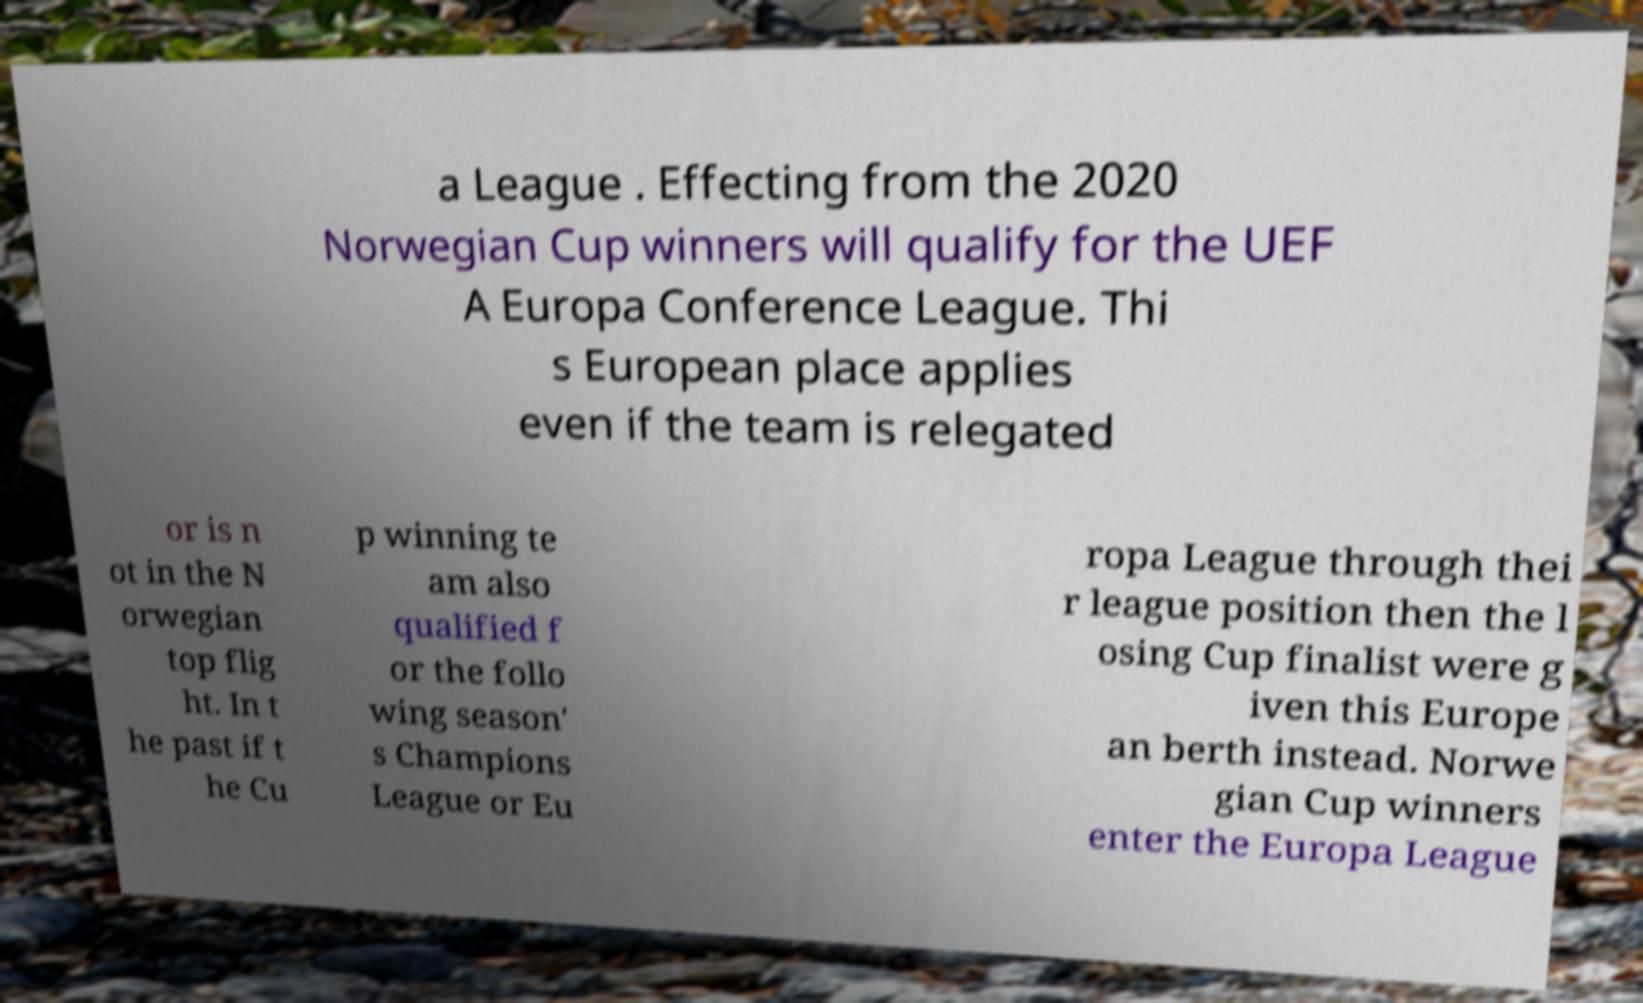Please identify and transcribe the text found in this image. a League . Effecting from the 2020 Norwegian Cup winners will qualify for the UEF A Europa Conference League. Thi s European place applies even if the team is relegated or is n ot in the N orwegian top flig ht. In t he past if t he Cu p winning te am also qualified f or the follo wing season' s Champions League or Eu ropa League through thei r league position then the l osing Cup finalist were g iven this Europe an berth instead. Norwe gian Cup winners enter the Europa League 